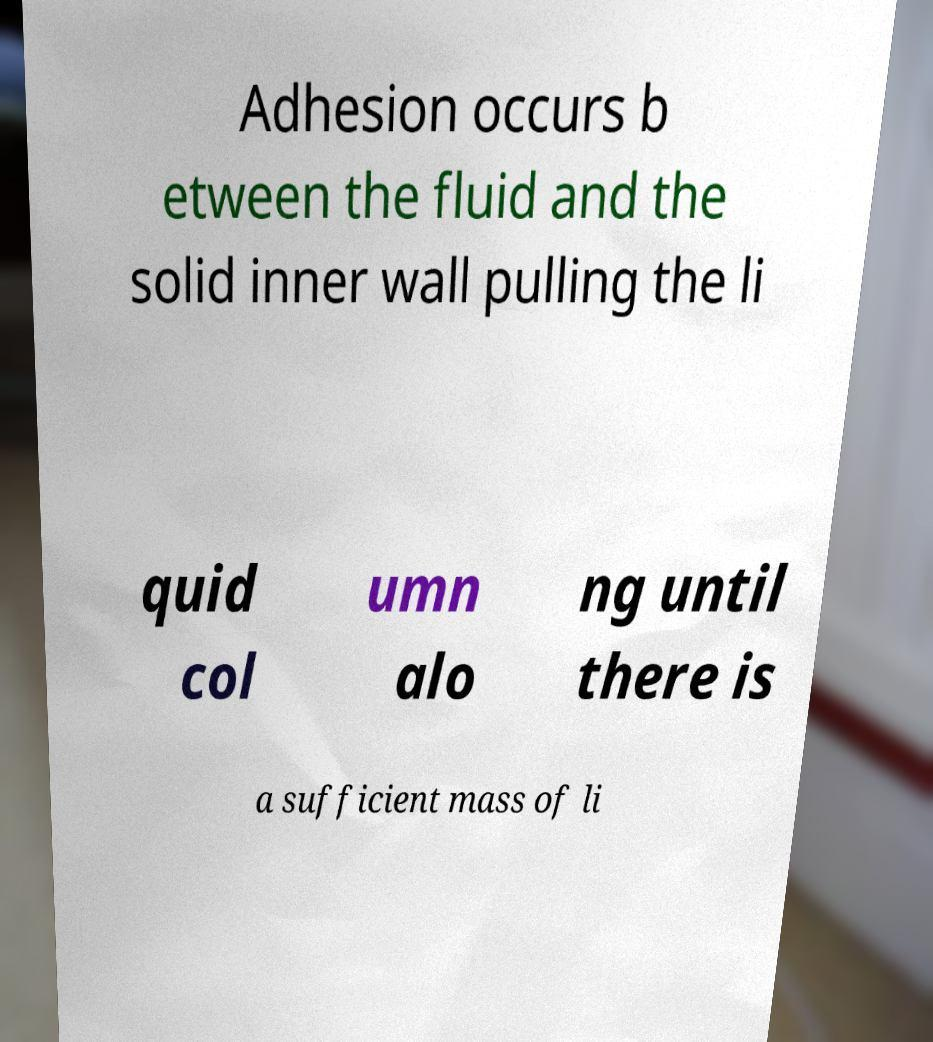What messages or text are displayed in this image? I need them in a readable, typed format. Adhesion occurs b etween the fluid and the solid inner wall pulling the li quid col umn alo ng until there is a sufficient mass of li 